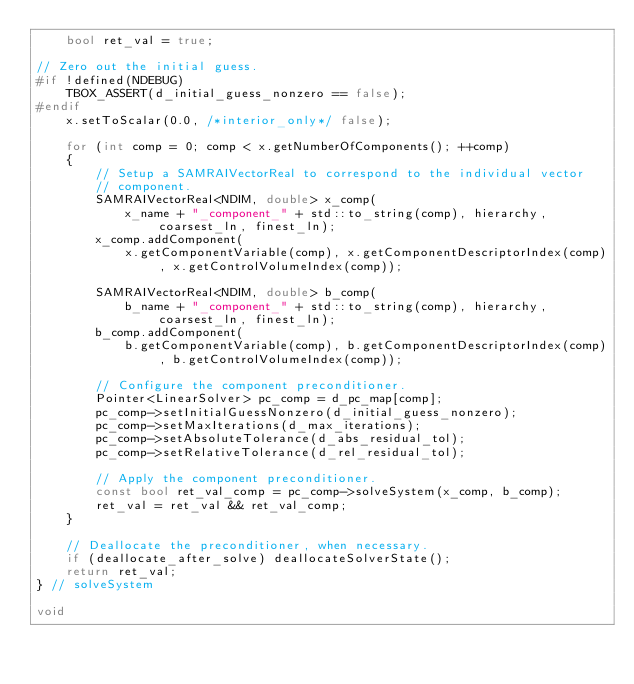<code> <loc_0><loc_0><loc_500><loc_500><_C++_>    bool ret_val = true;

// Zero out the initial guess.
#if !defined(NDEBUG)
    TBOX_ASSERT(d_initial_guess_nonzero == false);
#endif
    x.setToScalar(0.0, /*interior_only*/ false);

    for (int comp = 0; comp < x.getNumberOfComponents(); ++comp)
    {
        // Setup a SAMRAIVectorReal to correspond to the individual vector
        // component.
        SAMRAIVectorReal<NDIM, double> x_comp(
            x_name + "_component_" + std::to_string(comp), hierarchy, coarsest_ln, finest_ln);
        x_comp.addComponent(
            x.getComponentVariable(comp), x.getComponentDescriptorIndex(comp), x.getControlVolumeIndex(comp));

        SAMRAIVectorReal<NDIM, double> b_comp(
            b_name + "_component_" + std::to_string(comp), hierarchy, coarsest_ln, finest_ln);
        b_comp.addComponent(
            b.getComponentVariable(comp), b.getComponentDescriptorIndex(comp), b.getControlVolumeIndex(comp));

        // Configure the component preconditioner.
        Pointer<LinearSolver> pc_comp = d_pc_map[comp];
        pc_comp->setInitialGuessNonzero(d_initial_guess_nonzero);
        pc_comp->setMaxIterations(d_max_iterations);
        pc_comp->setAbsoluteTolerance(d_abs_residual_tol);
        pc_comp->setRelativeTolerance(d_rel_residual_tol);

        // Apply the component preconditioner.
        const bool ret_val_comp = pc_comp->solveSystem(x_comp, b_comp);
        ret_val = ret_val && ret_val_comp;
    }

    // Deallocate the preconditioner, when necessary.
    if (deallocate_after_solve) deallocateSolverState();
    return ret_val;
} // solveSystem

void</code> 